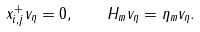<formula> <loc_0><loc_0><loc_500><loc_500>x _ { i , j } ^ { + } v _ { \eta } = 0 , \quad H _ { m } v _ { \eta } = \eta _ { m } v _ { \eta } .</formula> 